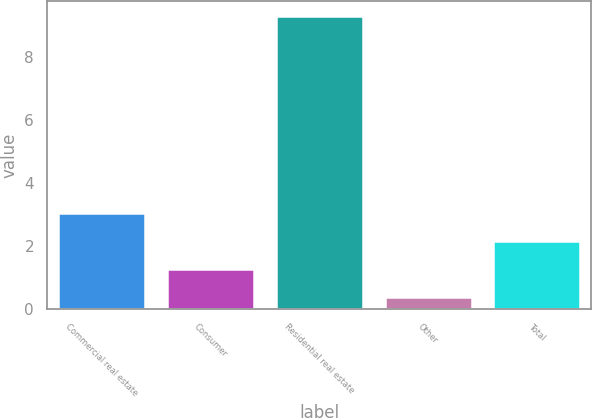Convert chart to OTSL. <chart><loc_0><loc_0><loc_500><loc_500><bar_chart><fcel>Commercial real estate<fcel>Consumer<fcel>Residential real estate<fcel>Other<fcel>Total<nl><fcel>3.06<fcel>1.27<fcel>9.32<fcel>0.37<fcel>2.17<nl></chart> 